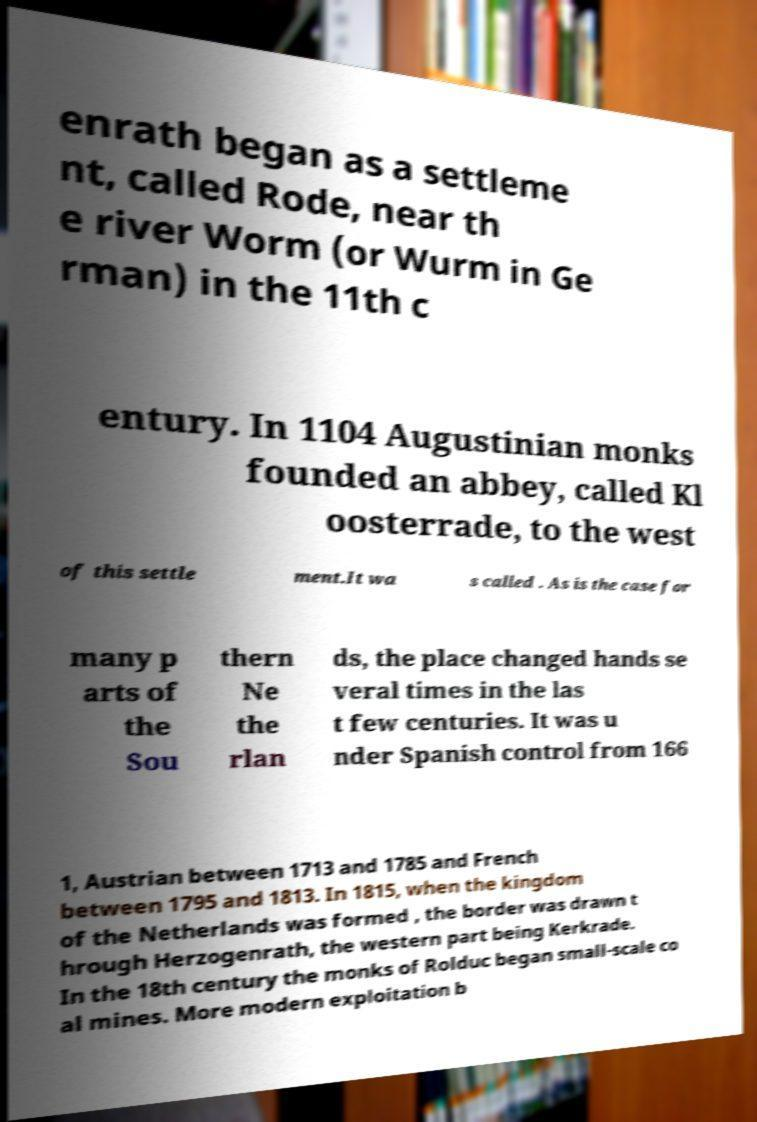Could you assist in decoding the text presented in this image and type it out clearly? enrath began as a settleme nt, called Rode, near th e river Worm (or Wurm in Ge rman) in the 11th c entury. In 1104 Augustinian monks founded an abbey, called Kl oosterrade, to the west of this settle ment.It wa s called . As is the case for many p arts of the Sou thern Ne the rlan ds, the place changed hands se veral times in the las t few centuries. It was u nder Spanish control from 166 1, Austrian between 1713 and 1785 and French between 1795 and 1813. In 1815, when the kingdom of the Netherlands was formed , the border was drawn t hrough Herzogenrath, the western part being Kerkrade. In the 18th century the monks of Rolduc began small-scale co al mines. More modern exploitation b 